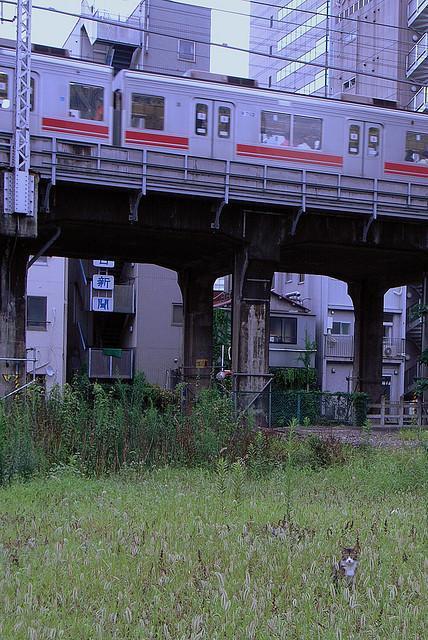How many giraffes are shown?
Give a very brief answer. 0. 